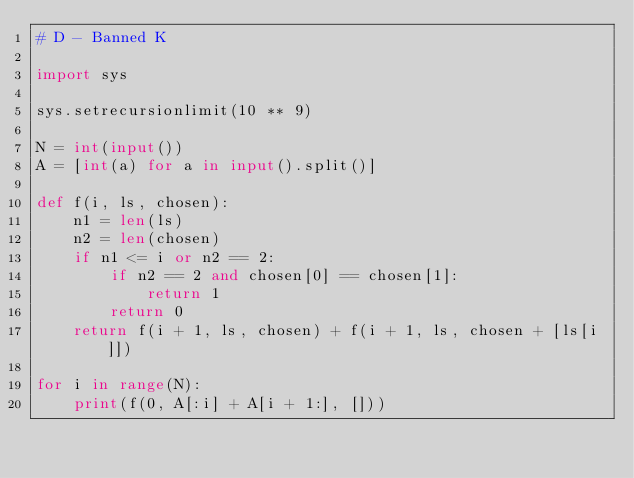<code> <loc_0><loc_0><loc_500><loc_500><_Python_># D - Banned K

import sys

sys.setrecursionlimit(10 ** 9)

N = int(input())
A = [int(a) for a in input().split()]

def f(i, ls, chosen):
    n1 = len(ls)
    n2 = len(chosen)
    if n1 <= i or n2 == 2:
        if n2 == 2 and chosen[0] == chosen[1]:
            return 1
        return 0
    return f(i + 1, ls, chosen) + f(i + 1, ls, chosen + [ls[i]])

for i in range(N):
    print(f(0, A[:i] + A[i + 1:], []))
</code> 